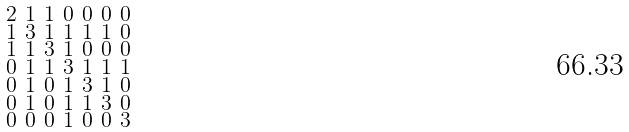<formula> <loc_0><loc_0><loc_500><loc_500>\begin{smallmatrix} 2 & 1 & 1 & 0 & 0 & 0 & 0 \\ 1 & 3 & 1 & 1 & 1 & 1 & 0 \\ 1 & 1 & 3 & 1 & 0 & 0 & 0 \\ 0 & 1 & 1 & 3 & 1 & 1 & 1 \\ 0 & 1 & 0 & 1 & 3 & 1 & 0 \\ 0 & 1 & 0 & 1 & 1 & 3 & 0 \\ 0 & 0 & 0 & 1 & 0 & 0 & 3 \end{smallmatrix}</formula> 